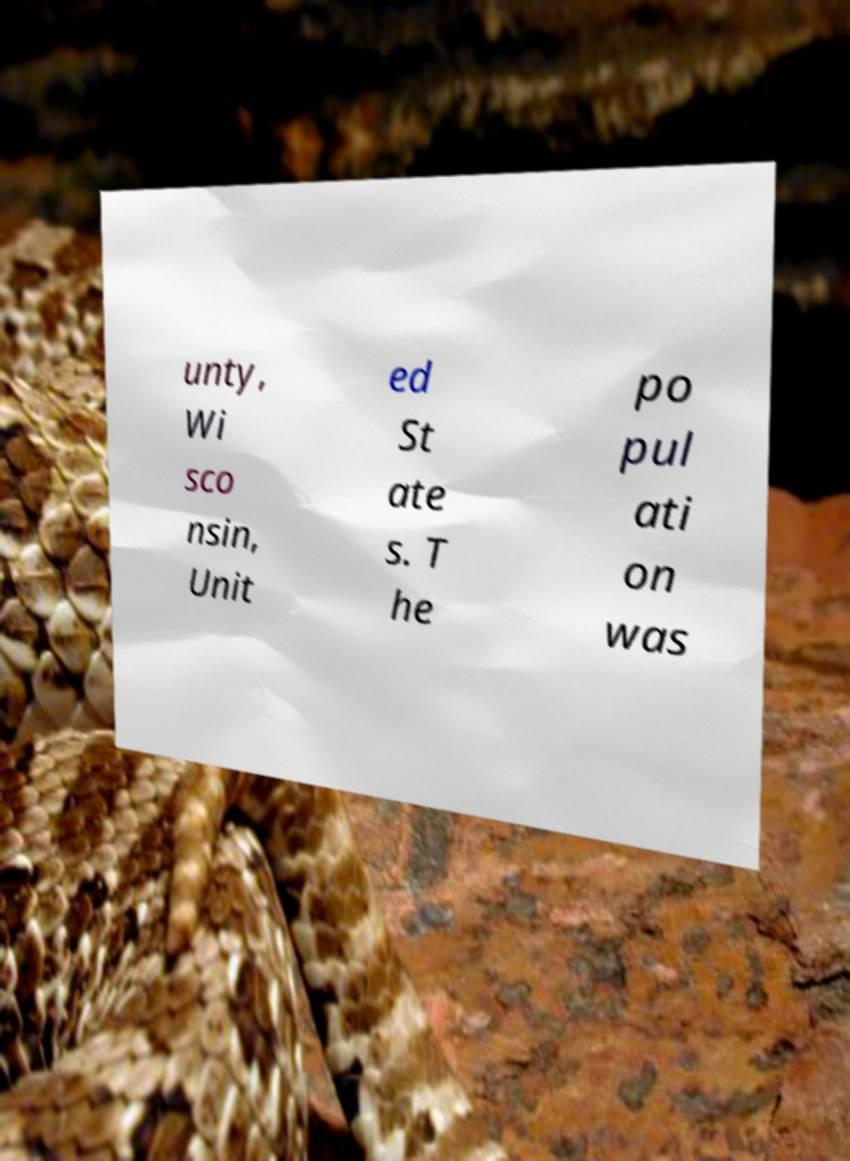There's text embedded in this image that I need extracted. Can you transcribe it verbatim? unty, Wi sco nsin, Unit ed St ate s. T he po pul ati on was 